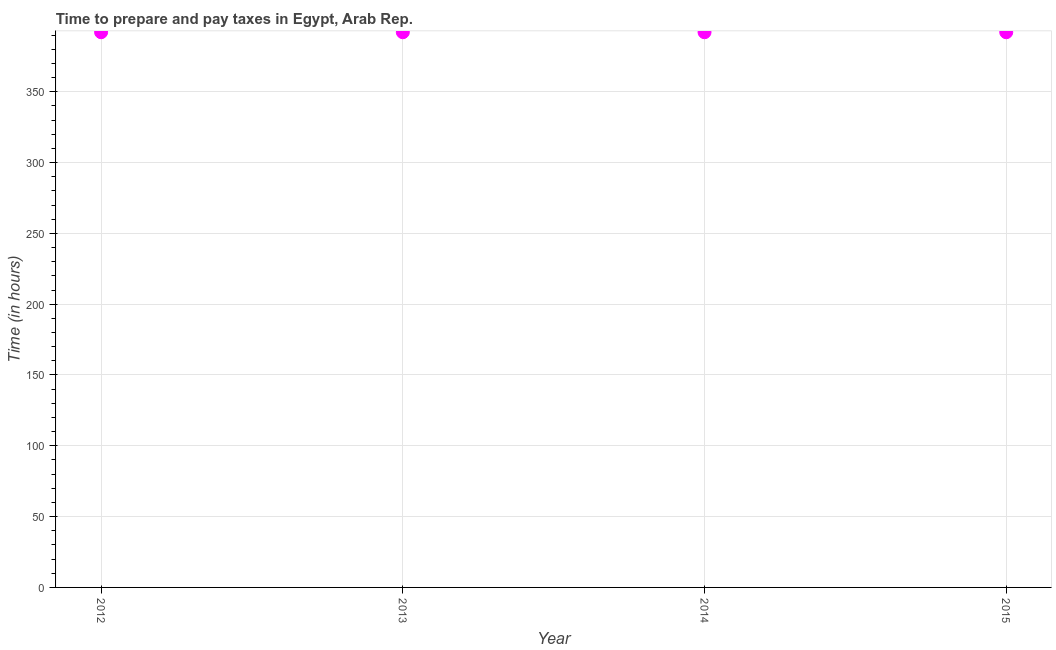What is the time to prepare and pay taxes in 2012?
Offer a very short reply. 392. Across all years, what is the maximum time to prepare and pay taxes?
Keep it short and to the point. 392. Across all years, what is the minimum time to prepare and pay taxes?
Keep it short and to the point. 392. In which year was the time to prepare and pay taxes maximum?
Ensure brevity in your answer.  2012. In which year was the time to prepare and pay taxes minimum?
Your response must be concise. 2012. What is the sum of the time to prepare and pay taxes?
Your answer should be compact. 1568. What is the average time to prepare and pay taxes per year?
Offer a terse response. 392. What is the median time to prepare and pay taxes?
Make the answer very short. 392. Do a majority of the years between 2013 and 2014 (inclusive) have time to prepare and pay taxes greater than 180 hours?
Make the answer very short. Yes. Is the difference between the time to prepare and pay taxes in 2012 and 2015 greater than the difference between any two years?
Your answer should be compact. Yes. What is the difference between the highest and the second highest time to prepare and pay taxes?
Keep it short and to the point. 0. Is the sum of the time to prepare and pay taxes in 2013 and 2015 greater than the maximum time to prepare and pay taxes across all years?
Provide a short and direct response. Yes. What is the difference between the highest and the lowest time to prepare and pay taxes?
Ensure brevity in your answer.  0. In how many years, is the time to prepare and pay taxes greater than the average time to prepare and pay taxes taken over all years?
Provide a succinct answer. 0. Does the time to prepare and pay taxes monotonically increase over the years?
Ensure brevity in your answer.  No. How many dotlines are there?
Give a very brief answer. 1. How many years are there in the graph?
Provide a succinct answer. 4. Does the graph contain any zero values?
Your answer should be compact. No. Does the graph contain grids?
Provide a short and direct response. Yes. What is the title of the graph?
Provide a succinct answer. Time to prepare and pay taxes in Egypt, Arab Rep. What is the label or title of the Y-axis?
Keep it short and to the point. Time (in hours). What is the Time (in hours) in 2012?
Ensure brevity in your answer.  392. What is the Time (in hours) in 2013?
Ensure brevity in your answer.  392. What is the Time (in hours) in 2014?
Your response must be concise. 392. What is the Time (in hours) in 2015?
Offer a terse response. 392. What is the difference between the Time (in hours) in 2012 and 2013?
Give a very brief answer. 0. What is the difference between the Time (in hours) in 2013 and 2015?
Your response must be concise. 0. What is the difference between the Time (in hours) in 2014 and 2015?
Give a very brief answer. 0. What is the ratio of the Time (in hours) in 2012 to that in 2014?
Offer a terse response. 1. What is the ratio of the Time (in hours) in 2013 to that in 2015?
Offer a very short reply. 1. 